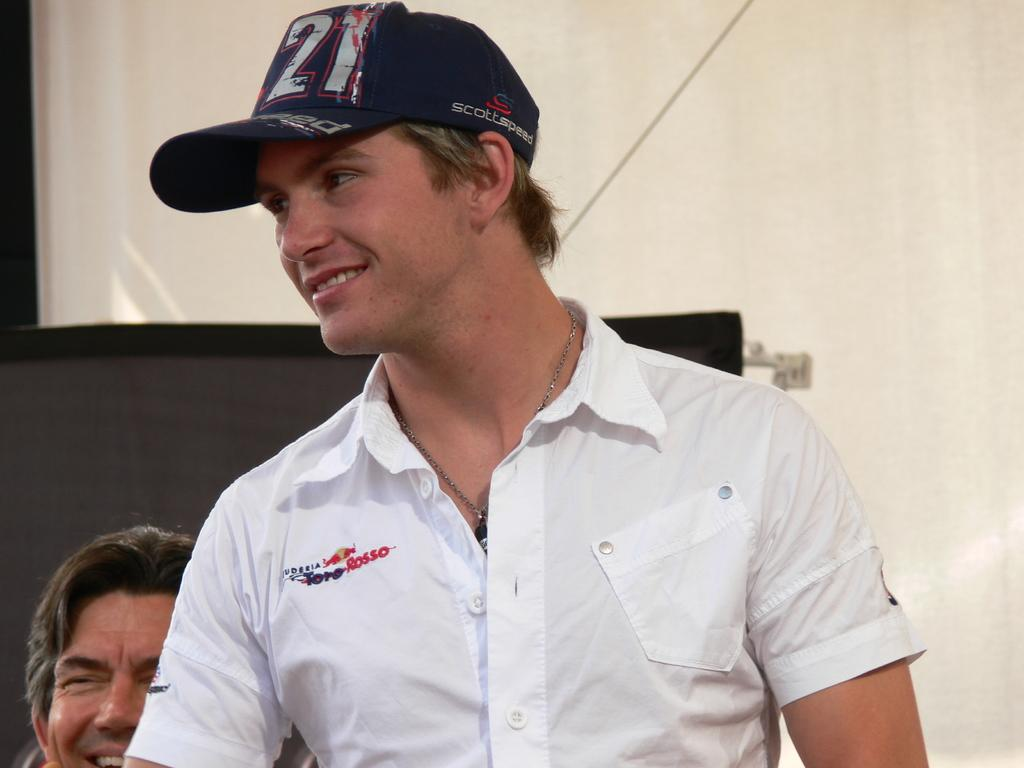<image>
Describe the image concisely. A man in a white shirt and baseball cap, the latter has the number 21 on it. 